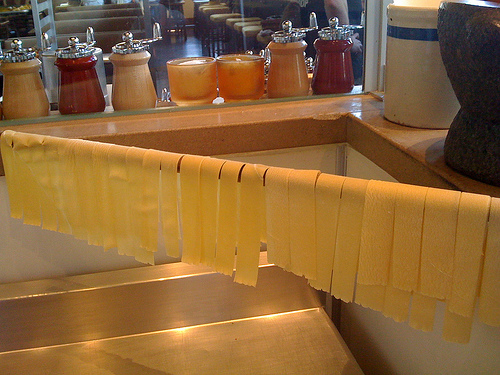<image>
Is there a pasta above the sink? Yes. The pasta is positioned above the sink in the vertical space, higher up in the scene. 